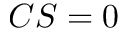<formula> <loc_0><loc_0><loc_500><loc_500>C S = 0</formula> 